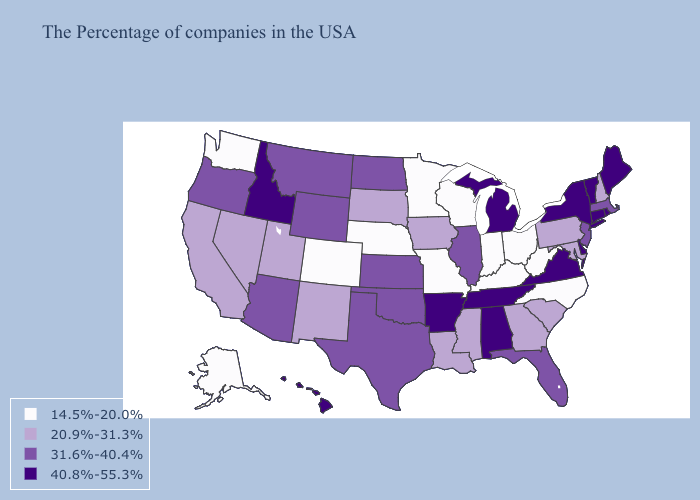How many symbols are there in the legend?
Short answer required. 4. Among the states that border Illinois , does Iowa have the lowest value?
Concise answer only. No. What is the highest value in states that border Alabama?
Write a very short answer. 40.8%-55.3%. Which states have the highest value in the USA?
Quick response, please. Maine, Rhode Island, Vermont, Connecticut, New York, Delaware, Virginia, Michigan, Alabama, Tennessee, Arkansas, Idaho, Hawaii. Name the states that have a value in the range 14.5%-20.0%?
Keep it brief. North Carolina, West Virginia, Ohio, Kentucky, Indiana, Wisconsin, Missouri, Minnesota, Nebraska, Colorado, Washington, Alaska. What is the lowest value in the West?
Be succinct. 14.5%-20.0%. Does North Carolina have the lowest value in the USA?
Write a very short answer. Yes. What is the value of California?
Write a very short answer. 20.9%-31.3%. Name the states that have a value in the range 20.9%-31.3%?
Quick response, please. New Hampshire, Maryland, Pennsylvania, South Carolina, Georgia, Mississippi, Louisiana, Iowa, South Dakota, New Mexico, Utah, Nevada, California. What is the value of Idaho?
Quick response, please. 40.8%-55.3%. Name the states that have a value in the range 14.5%-20.0%?
Quick response, please. North Carolina, West Virginia, Ohio, Kentucky, Indiana, Wisconsin, Missouri, Minnesota, Nebraska, Colorado, Washington, Alaska. Does the first symbol in the legend represent the smallest category?
Answer briefly. Yes. What is the lowest value in states that border Connecticut?
Write a very short answer. 31.6%-40.4%. What is the value of Wyoming?
Give a very brief answer. 31.6%-40.4%. Does the map have missing data?
Quick response, please. No. 